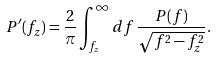<formula> <loc_0><loc_0><loc_500><loc_500>P ^ { \prime } ( f _ { z } ) = \frac { 2 } { \pi } \int _ { f _ { z } } ^ { \infty } d f \, \frac { P ( f ) } { \sqrt { f ^ { 2 } - f _ { z } ^ { 2 } } } .</formula> 